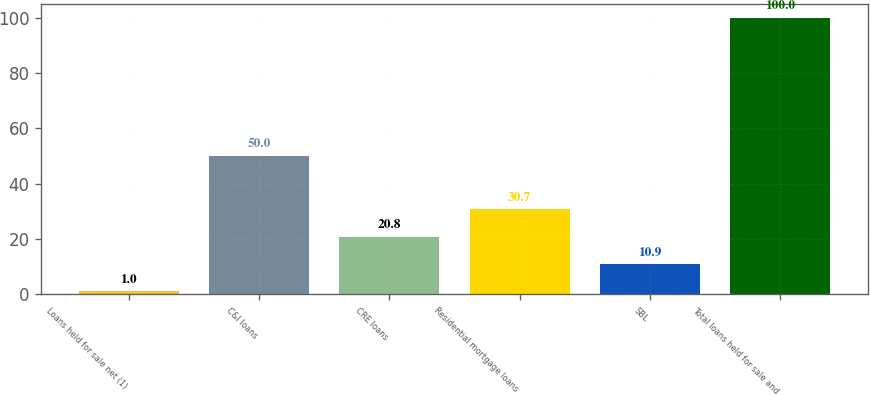Convert chart. <chart><loc_0><loc_0><loc_500><loc_500><bar_chart><fcel>Loans held for sale net (1)<fcel>C&I loans<fcel>CRE loans<fcel>Residential mortgage loans<fcel>SBL<fcel>Total loans held for sale and<nl><fcel>1<fcel>50<fcel>20.8<fcel>30.7<fcel>10.9<fcel>100<nl></chart> 